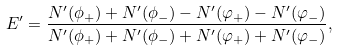Convert formula to latex. <formula><loc_0><loc_0><loc_500><loc_500>E ^ { \prime } = \frac { N ^ { \prime } ( \phi _ { + } ) + N ^ { \prime } ( \phi _ { - } ) - N ^ { \prime } ( \varphi _ { + } ) - N ^ { \prime } ( \varphi _ { - } ) } { N ^ { \prime } ( \phi _ { + } ) + N ^ { \prime } ( \phi _ { - } ) + N ^ { \prime } ( \varphi _ { + } ) + N ^ { \prime } ( \varphi _ { - } ) } ,</formula> 